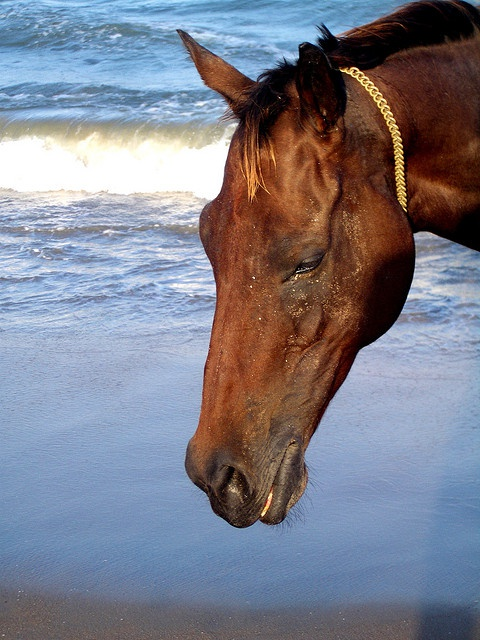Describe the objects in this image and their specific colors. I can see a horse in gray, maroon, black, and brown tones in this image. 